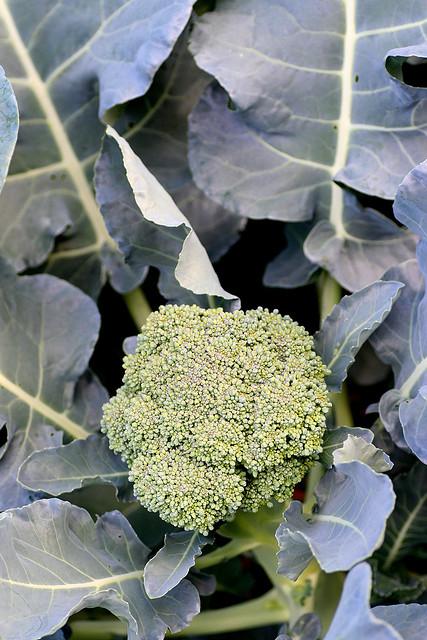Is this plant edible?
Quick response, please. Yes. Is there water on this vegetable?
Keep it brief. No. What kind of vegetable is this?
Write a very short answer. Broccoli. Is it ready to be picked?
Quick response, please. Yes. 